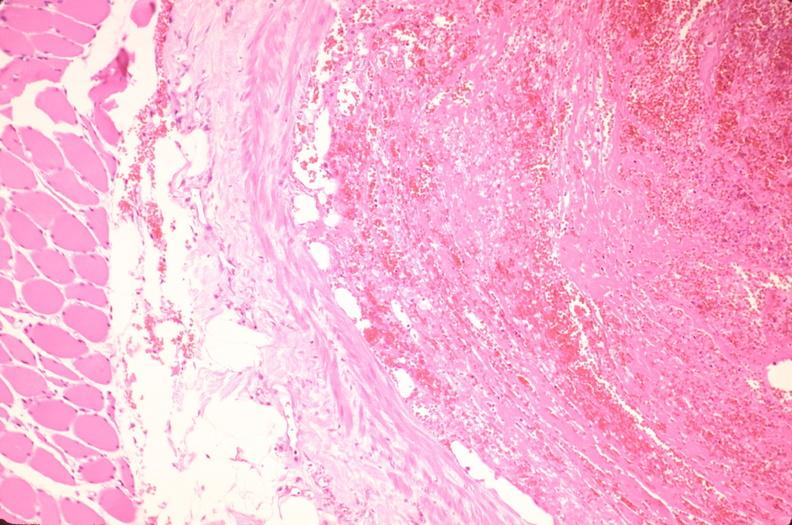what does this image show?
Answer the question using a single word or phrase. Thrombus in leg vein with early organization 